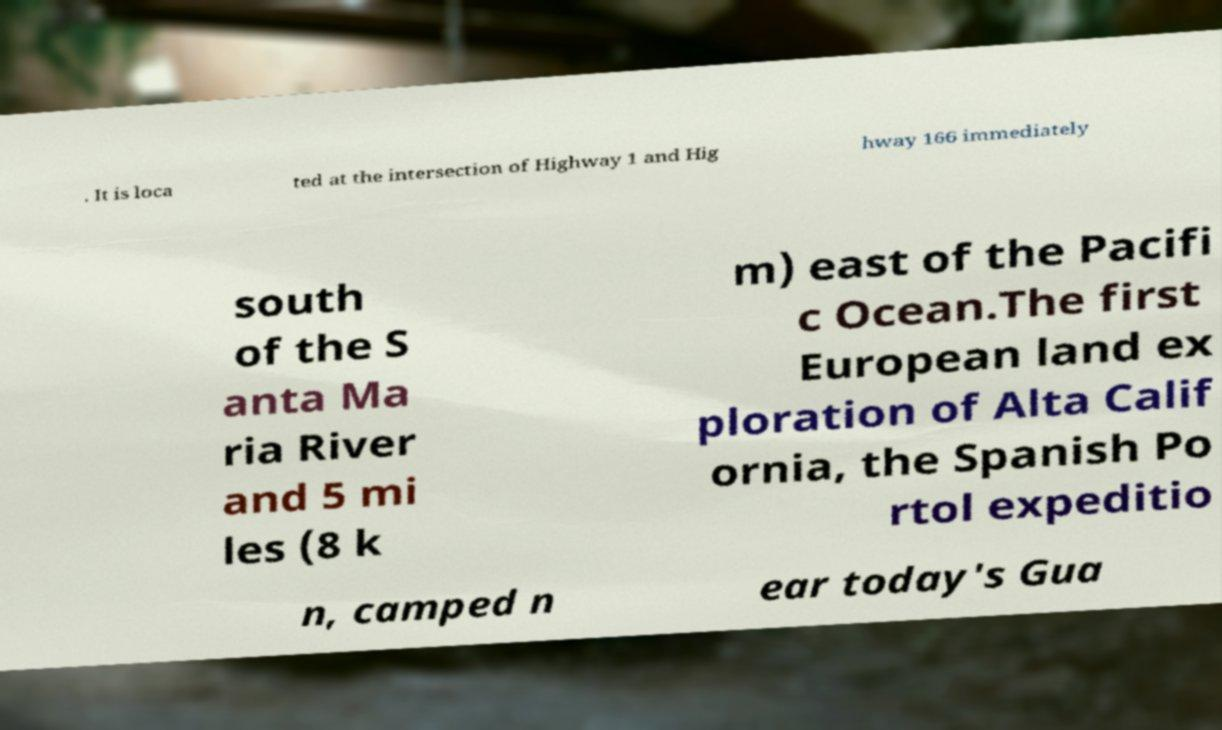What messages or text are displayed in this image? I need them in a readable, typed format. . It is loca ted at the intersection of Highway 1 and Hig hway 166 immediately south of the S anta Ma ria River and 5 mi les (8 k m) east of the Pacifi c Ocean.The first European land ex ploration of Alta Calif ornia, the Spanish Po rtol expeditio n, camped n ear today's Gua 